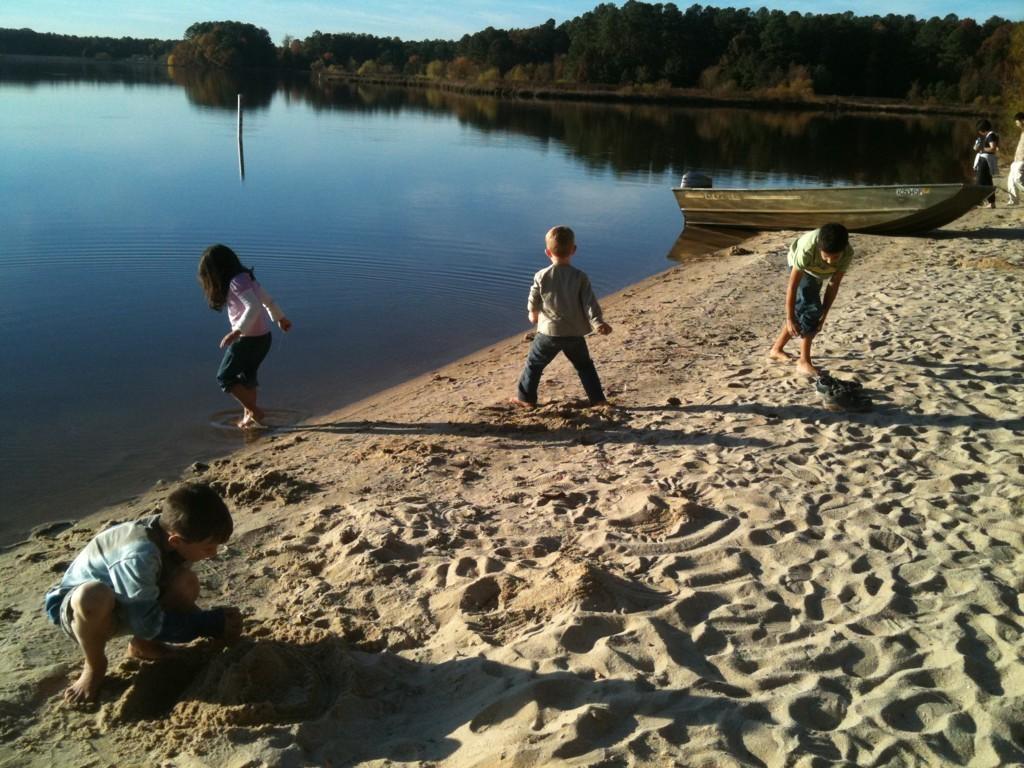Could you give a brief overview of what you see in this image? In this image we can see there are children, sand and a boat. There is water. There are trees. In the background we can see the sky. 